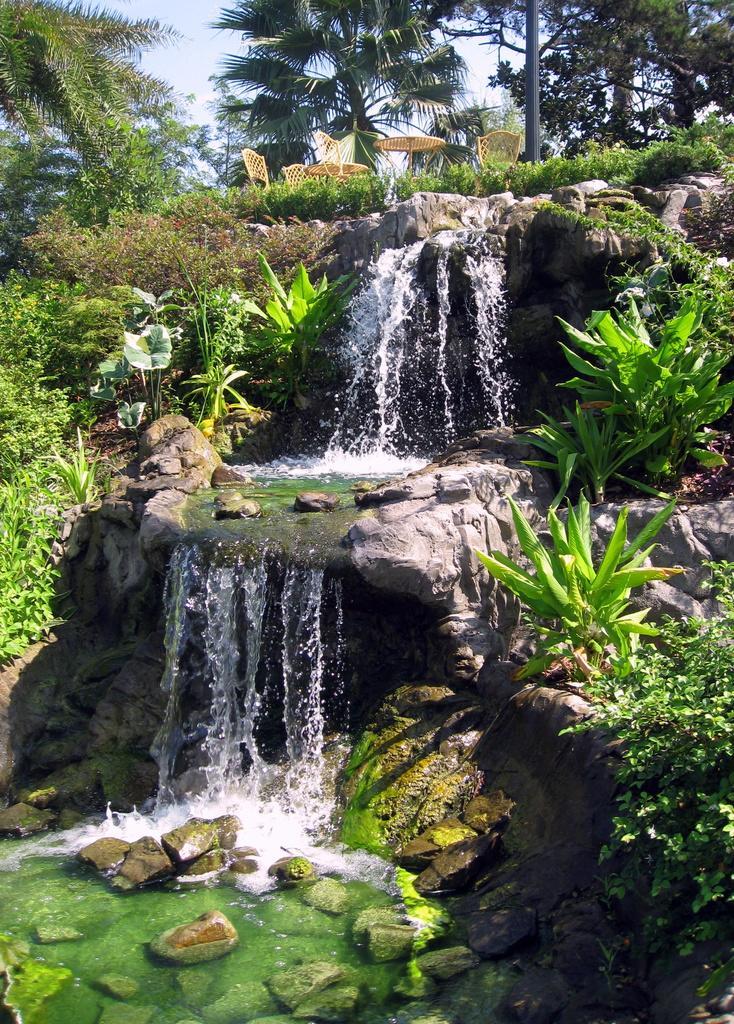Please provide a concise description of this image. This picture is clicked outside the city. In the foreground we can see a water body, a waterfall and the rocks and we can see the plants and grass. At the top there is a sky, trees and a table and some chairs. 